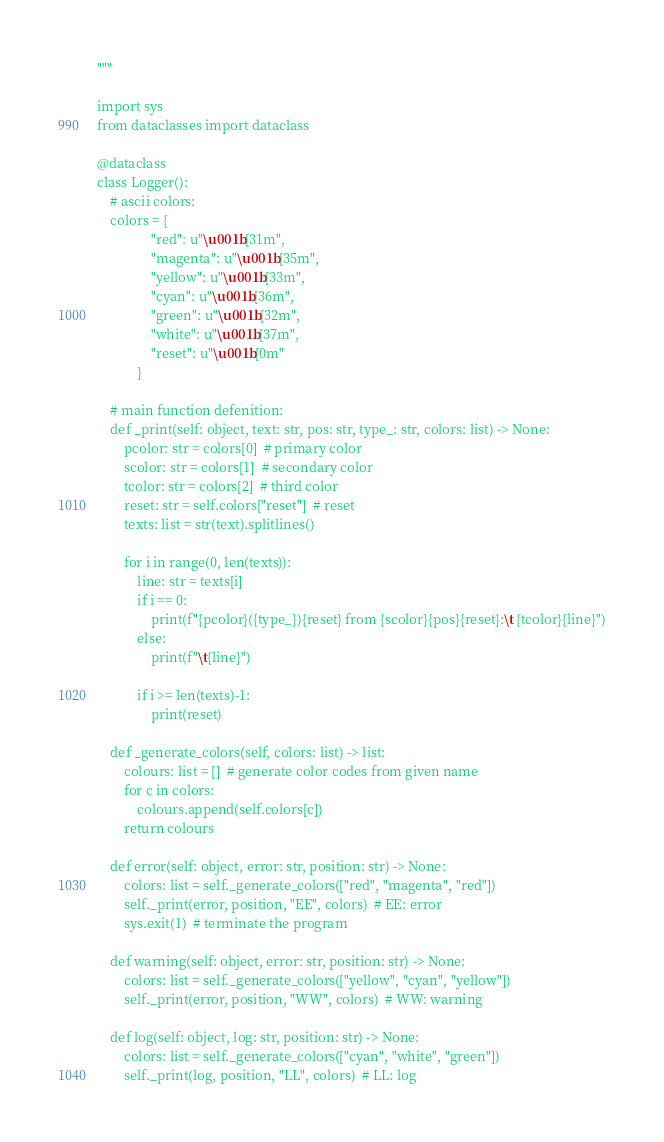<code> <loc_0><loc_0><loc_500><loc_500><_Python_>"""

import sys
from dataclasses import dataclass

@dataclass
class Logger():
    # ascii colors:
    colors = {
                "red": u"\u001b[31m",
                "magenta": u"\u001b[35m",
                "yellow": u"\u001b[33m",
                "cyan": u"\u001b[36m",
                "green": u"\u001b[32m",
                "white": u"\u001b[37m",
                "reset": u"\u001b[0m"
            }

    # main function defenition:
    def _print(self: object, text: str, pos: str, type_: str, colors: list) -> None:
        pcolor: str = colors[0]  # primary color
        scolor: str = colors[1]  # secondary color
        tcolor: str = colors[2]  # third color
        reset: str = self.colors["reset"]  # reset
        texts: list = str(text).splitlines()
        
        for i in range(0, len(texts)):
            line: str = texts[i]
            if i == 0:
                print(f"{pcolor}({type_}){reset} from {scolor}{pos}{reset}:\t {tcolor}{line}")
            else:
                print(f"\t{line}")

            if i >= len(texts)-1:
                print(reset)

    def _generate_colors(self, colors: list) -> list:
        colours: list = []  # generate color codes from given name
        for c in colors:
            colours.append(self.colors[c])
        return colours

    def error(self: object, error: str, position: str) -> None:
        colors: list = self._generate_colors(["red", "magenta", "red"])
        self._print(error, position, "EE", colors)  # EE: error
        sys.exit(1)  # terminate the program

    def warning(self: object, error: str, position: str) -> None:
        colors: list = self._generate_colors(["yellow", "cyan", "yellow"])
        self._print(error, position, "WW", colors)  # WW: warning

    def log(self: object, log: str, position: str) -> None:
        colors: list = self._generate_colors(["cyan", "white", "green"])
        self._print(log, position, "LL", colors)  # LL: log

</code> 